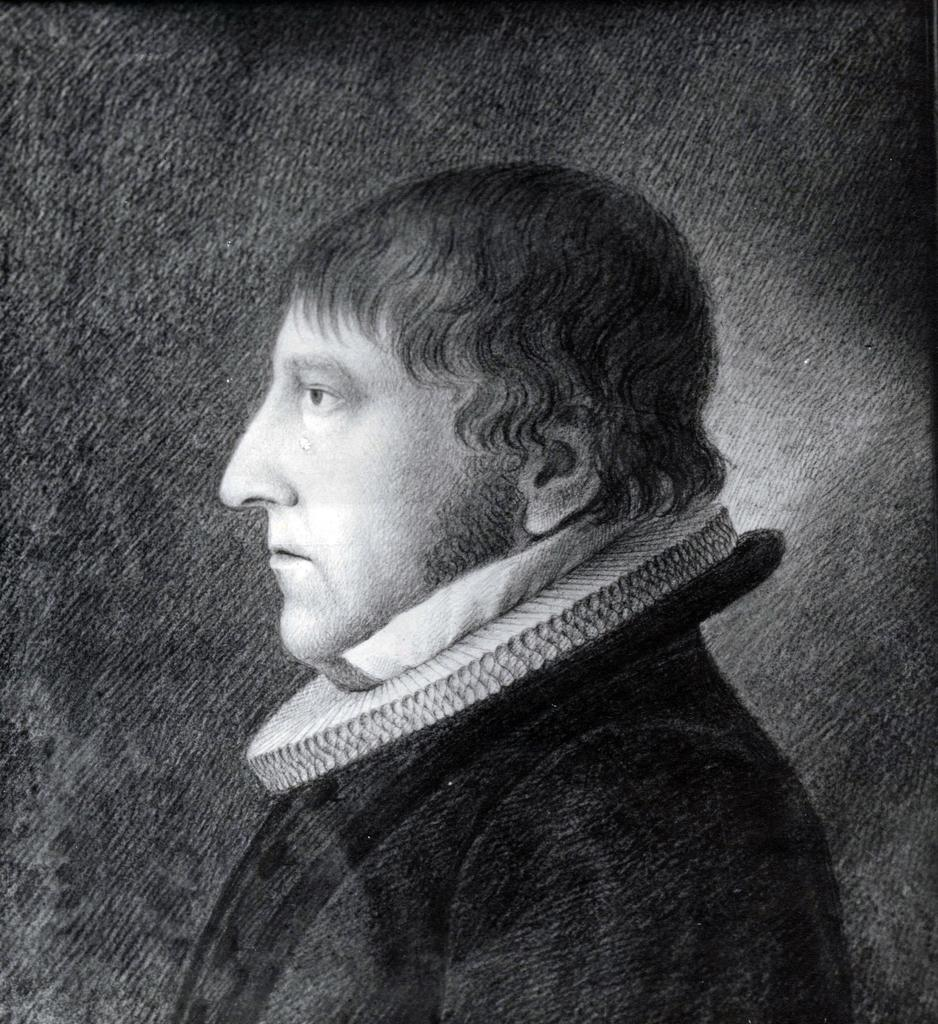What is the main subject of the image? There is a person in the image. What color scheme is used in the image? The image is in black and white. How many sheep can be seen in the image? There are no sheep present in the image. What type of trip is the person taking in the image? The image does not provide any information about a trip or any other activities the person might be engaged in. 